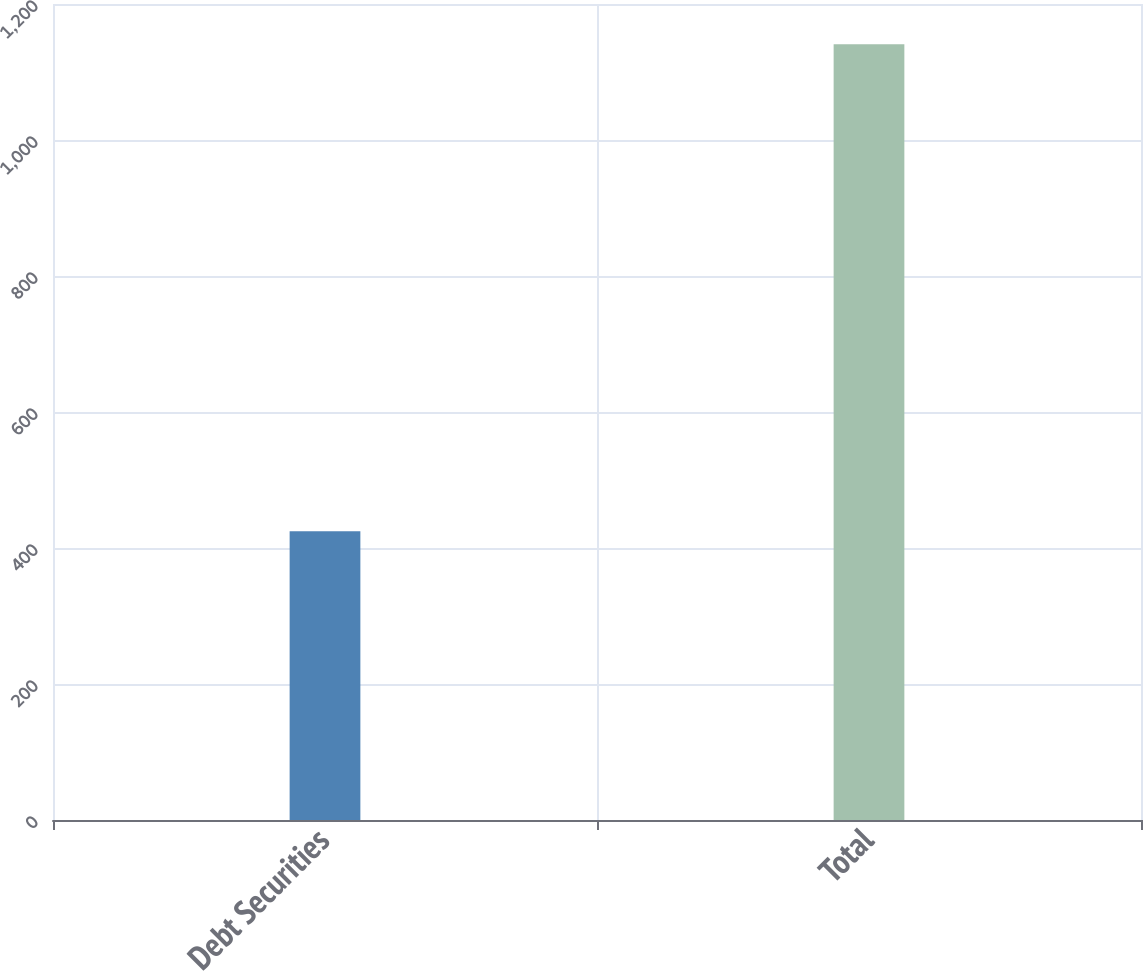Convert chart. <chart><loc_0><loc_0><loc_500><loc_500><bar_chart><fcel>Debt Securities<fcel>Total<nl><fcel>424.8<fcel>1140.7<nl></chart> 